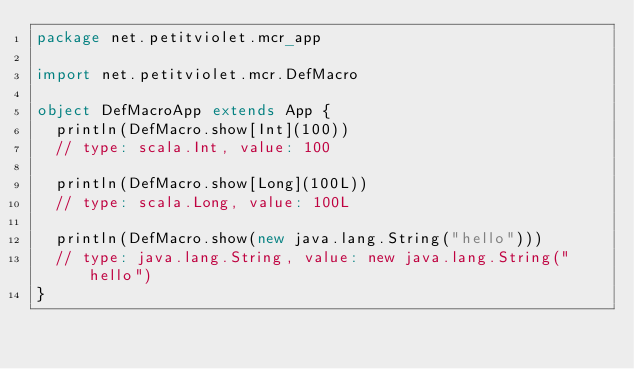Convert code to text. <code><loc_0><loc_0><loc_500><loc_500><_Scala_>package net.petitviolet.mcr_app

import net.petitviolet.mcr.DefMacro

object DefMacroApp extends App {
  println(DefMacro.show[Int](100))
  // type: scala.Int, value: 100

  println(DefMacro.show[Long](100L))
  // type: scala.Long, value: 100L

  println(DefMacro.show(new java.lang.String("hello")))
  // type: java.lang.String, value: new java.lang.String("hello")
}
</code> 